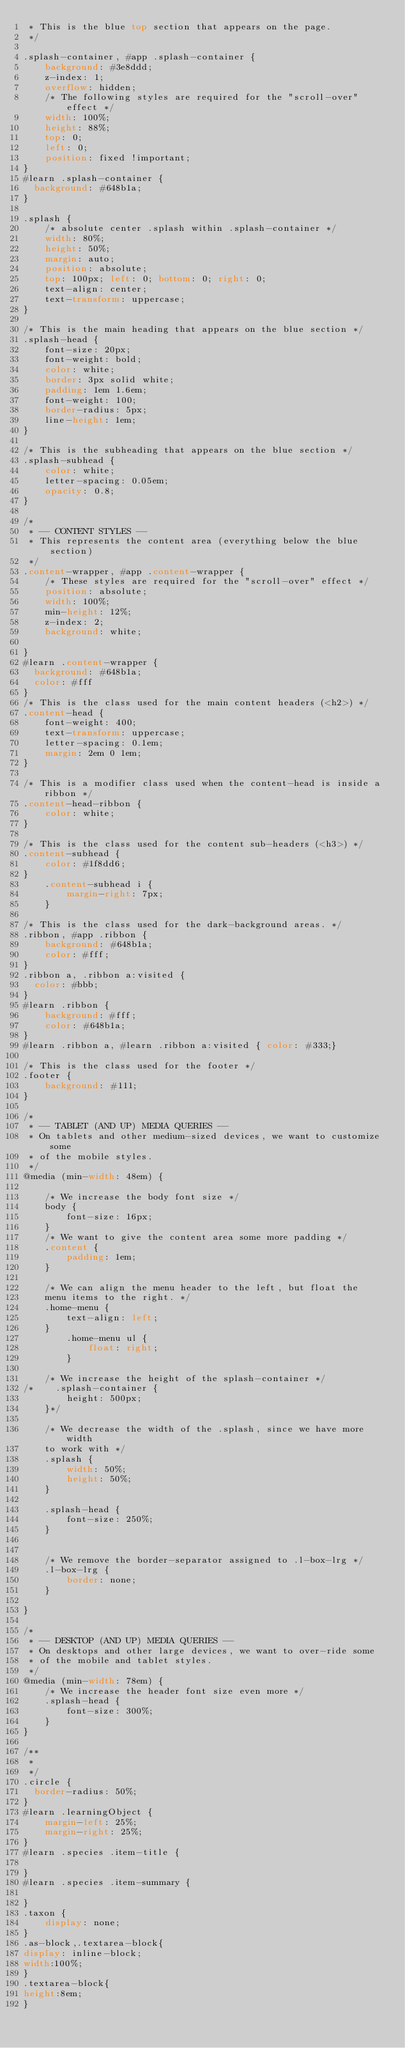Convert code to text. <code><loc_0><loc_0><loc_500><loc_500><_CSS_> * This is the blue top section that appears on the page.
 */

.splash-container, #app .splash-container {
    background: #3e8ddd;
    z-index: 1;
    overflow: hidden;
    /* The following styles are required for the "scroll-over" effect */
    width: 100%;
    height: 88%;
    top: 0;
    left: 0;
    position: fixed !important;
}
#learn .splash-container {
	background: #648b1a;
}

.splash {
    /* absolute center .splash within .splash-container */
    width: 80%;
    height: 50%;
    margin: auto;
    position: absolute;
    top: 100px; left: 0; bottom: 0; right: 0;
    text-align: center;
    text-transform: uppercase;
}

/* This is the main heading that appears on the blue section */
.splash-head {
    font-size: 20px;
    font-weight: bold;
    color: white;
    border: 3px solid white;
    padding: 1em 1.6em;
    font-weight: 100;
    border-radius: 5px;
    line-height: 1em;
}

/* This is the subheading that appears on the blue section */
.splash-subhead {
    color: white;
    letter-spacing: 0.05em;
    opacity: 0.8;
}

/*
 * -- CONTENT STYLES --
 * This represents the content area (everything below the blue section)
 */
.content-wrapper, #app .content-wrapper {
    /* These styles are required for the "scroll-over" effect */
    position: absolute;
    width: 100%;
    min-height: 12%;
    z-index: 2;
    background: white;

}
#learn .content-wrapper {
	background: #648b1a;
	color: #fff
}
/* This is the class used for the main content headers (<h2>) */
.content-head {
    font-weight: 400;
    text-transform: uppercase;
    letter-spacing: 0.1em;
    margin: 2em 0 1em;
}

/* This is a modifier class used when the content-head is inside a ribbon */
.content-head-ribbon {
    color: white;
}

/* This is the class used for the content sub-headers (<h3>) */
.content-subhead {
    color: #1f8dd6;
}
    .content-subhead i {
        margin-right: 7px;
    }

/* This is the class used for the dark-background areas. */
.ribbon, #app .ribbon {
    background: #648b1a;
    color: #fff;
}
.ribbon a, .ribbon a:visited {
	color: #bbb;
}
#learn .ribbon {
    background: #fff;
    color: #648b1a;
}
#learn .ribbon a, #learn .ribbon a:visited { color: #333;} 

/* This is the class used for the footer */
.footer {
    background: #111;
}

/*
 * -- TABLET (AND UP) MEDIA QUERIES --
 * On tablets and other medium-sized devices, we want to customize some
 * of the mobile styles.
 */
@media (min-width: 48em) {

    /* We increase the body font size */
    body {
        font-size: 16px;
    }
    /* We want to give the content area some more padding */
    .content {
        padding: 1em;
    }

    /* We can align the menu header to the left, but float the
    menu items to the right. */
    .home-menu {
        text-align: left;
    }
        .home-menu ul {
            float: right;
        }

    /* We increase the height of the splash-container */
/*    .splash-container {
        height: 500px;
    }*/

    /* We decrease the width of the .splash, since we have more width
    to work with */
    .splash {
        width: 50%;
        height: 50%;
    }

    .splash-head {
        font-size: 250%;
    }


    /* We remove the border-separator assigned to .l-box-lrg */
    .l-box-lrg {
        border: none;
    }

}

/*
 * -- DESKTOP (AND UP) MEDIA QUERIES --
 * On desktops and other large devices, we want to over-ride some
 * of the mobile and tablet styles.
 */
@media (min-width: 78em) {
    /* We increase the header font size even more */
    .splash-head {
        font-size: 300%;
    }
}

/**
 * 	
 */
.circle {
	border-radius: 50%;
}
#learn .learningObject {
    margin-left: 25%;
    margin-right: 25%;
} 
#learn .species .item-title {

}
#learn .species .item-summary {

}
.taxon {
    display: none;
}
.as-block,.textarea-block{
display: inline-block;
width:100%;
}
.textarea-block{
height:8em;
}</code> 